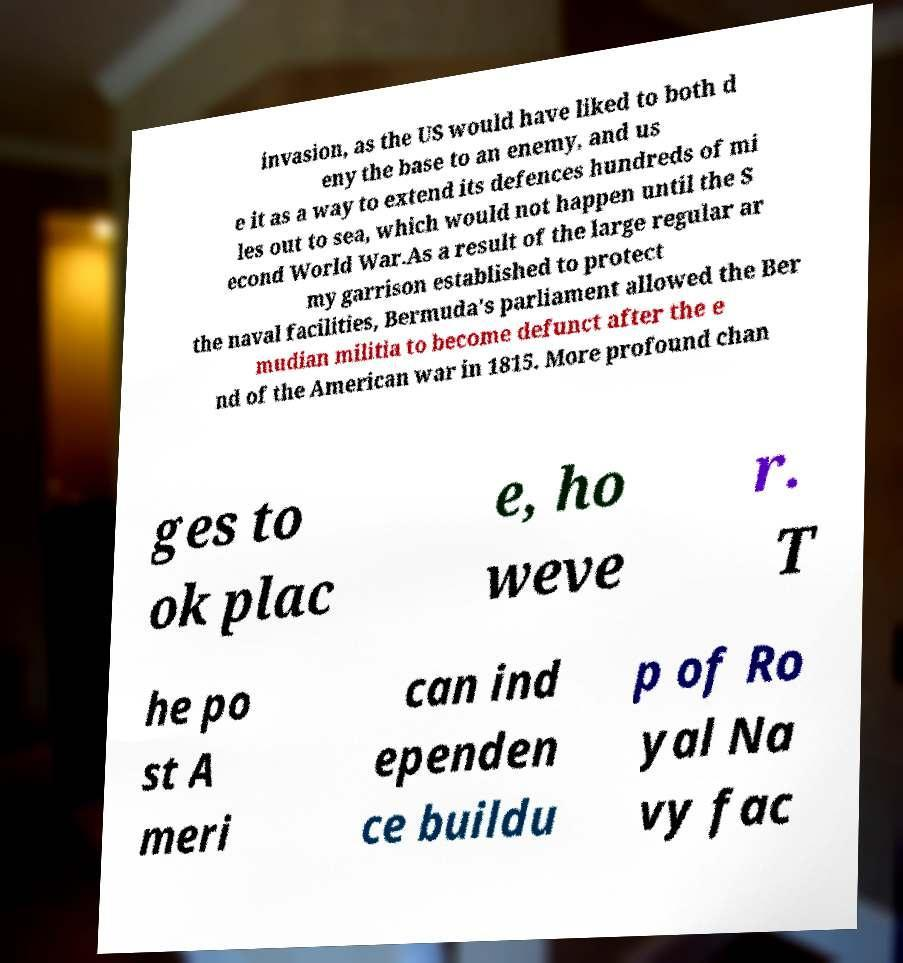Can you read and provide the text displayed in the image?This photo seems to have some interesting text. Can you extract and type it out for me? invasion, as the US would have liked to both d eny the base to an enemy, and us e it as a way to extend its defences hundreds of mi les out to sea, which would not happen until the S econd World War.As a result of the large regular ar my garrison established to protect the naval facilities, Bermuda's parliament allowed the Ber mudian militia to become defunct after the e nd of the American war in 1815. More profound chan ges to ok plac e, ho weve r. T he po st A meri can ind ependen ce buildu p of Ro yal Na vy fac 